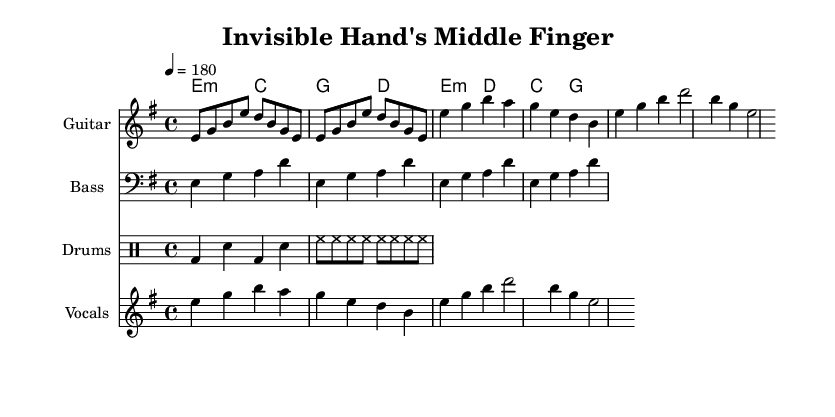What is the key signature of this music? The key signature is E minor, indicated by the presence of one sharp (F#) in the key signature section.
Answer: E minor What is the time signature of this music? The time signature shown in the music is 4/4, as specified at the beginning and indicated by the "4" above the "4".
Answer: 4/4 What is the tempo marking for this piece? The tempo marking is indicated as 4 = 180, meaning there are 180 beats per minute.
Answer: 180 How many measures are present in the verse section? The verse section consists of 4 measures, which can be counted from the placement of the chords and the vocal melody.
Answer: 4 What instruments are included in the score? The score includes guitar, bass, drums, and vocals, as indicated by the labeled staff sections in the music.
Answer: Guitar, bass, drums, vocals How many times does the guitar riff repeat? The guitar riff is written to repeat 2 times as indicated by the "repeat unfold 2" notation before the riff.
Answer: 2 What lyrical theme does the chorus suggest? The lyrics of the chorus suggest a theme of rebellion and resistance against the system, highlighted by the line "Smash the system, break the chains."
Answer: Rebellion 